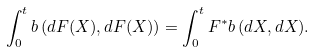Convert formula to latex. <formula><loc_0><loc_0><loc_500><loc_500>\int _ { 0 } ^ { t } b \, ( d F ( X ) , d F ( X ) ) = \int _ { 0 } ^ { t } F ^ { * } b \, ( d X , d X ) .</formula> 